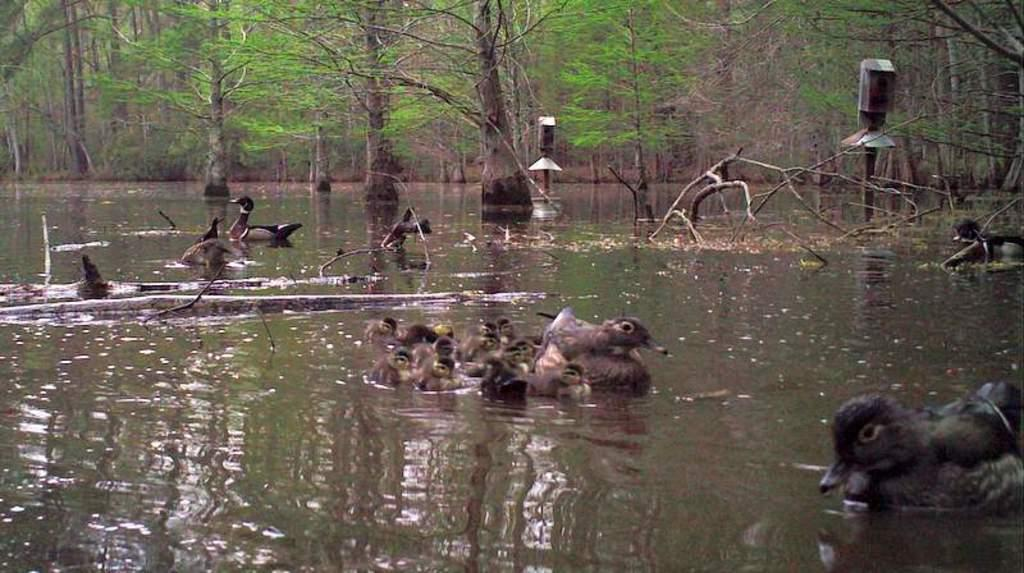What is the main element present in the image? There is water in the image. What type of animals can be seen in the water? There are ducks and ducklings in the water. What else can be found in the water? There are stems in the water. What can be seen in the background of the image? There are trees and poles in the water in the background of the image. What color is the man's eye in the image? There is no man present in the image, so it is not possible to determine the color of his eye. 